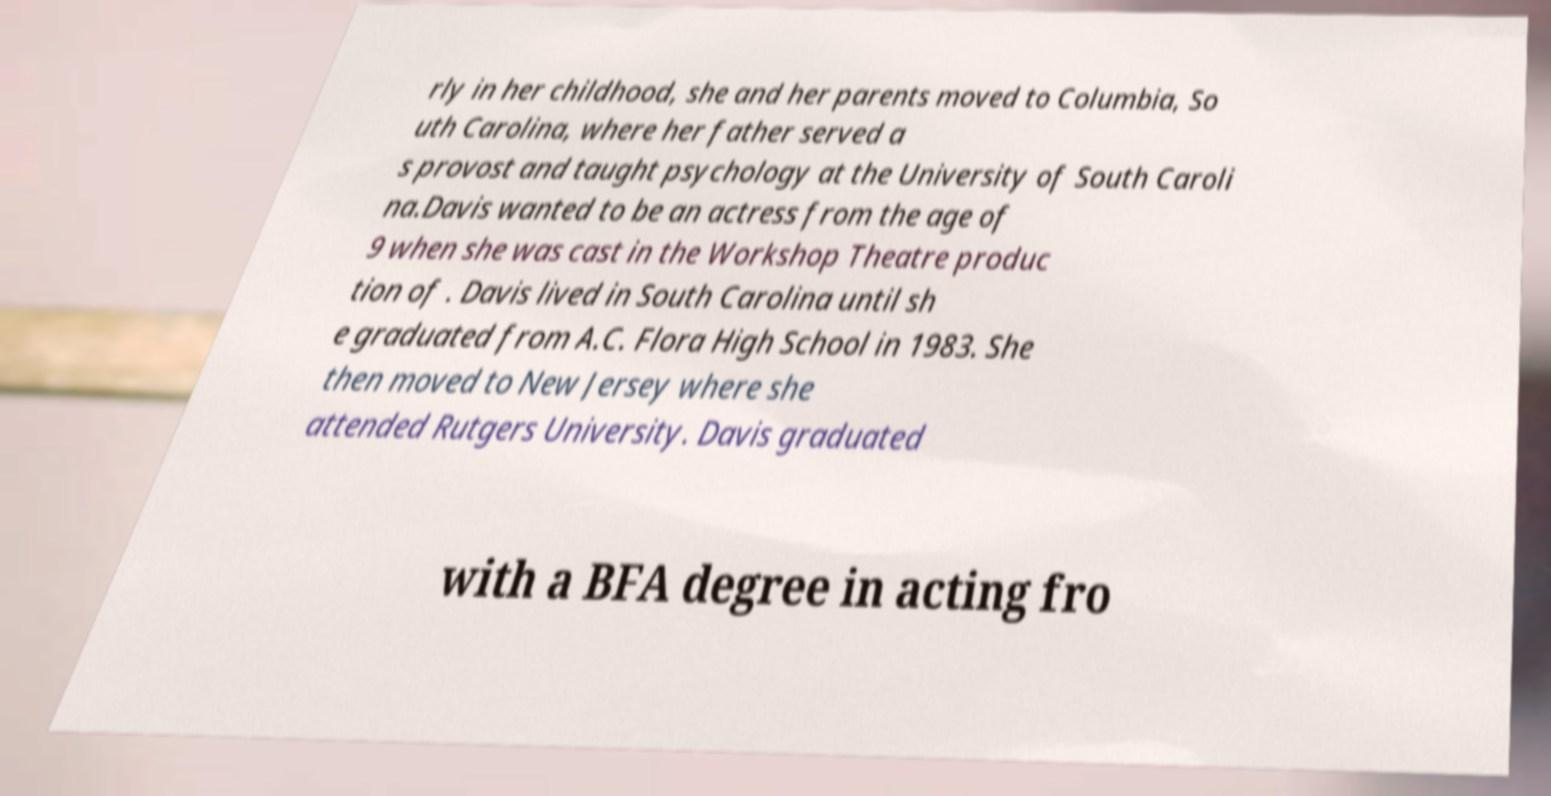Please read and relay the text visible in this image. What does it say? rly in her childhood, she and her parents moved to Columbia, So uth Carolina, where her father served a s provost and taught psychology at the University of South Caroli na.Davis wanted to be an actress from the age of 9 when she was cast in the Workshop Theatre produc tion of . Davis lived in South Carolina until sh e graduated from A.C. Flora High School in 1983. She then moved to New Jersey where she attended Rutgers University. Davis graduated with a BFA degree in acting fro 